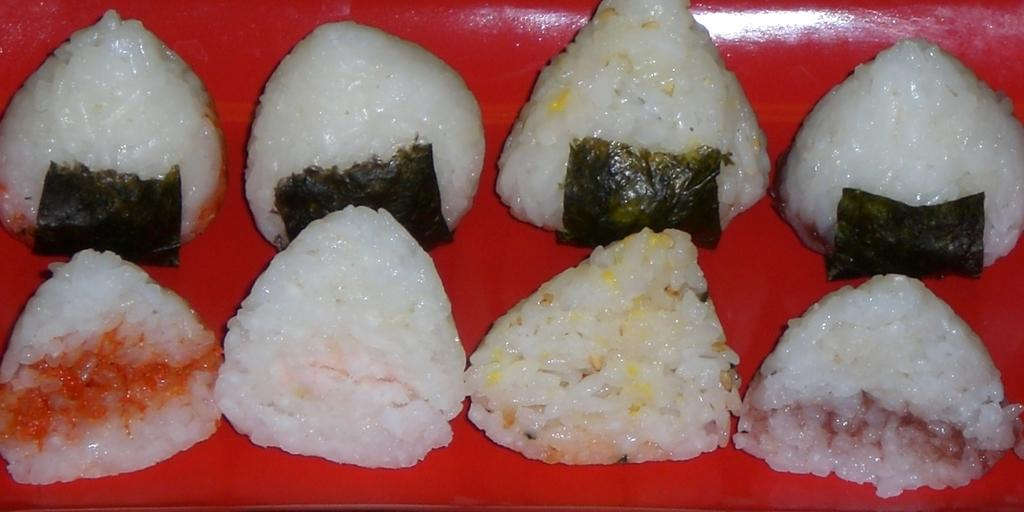How many pieces of rice cakes are visible in the image? There are eight pieces of rice cakes in the image. Where are the rice cakes placed? The rice cakes are placed on a plate. What is the color of the plate? The plate is red in color. What type of cord is used to hold the rice cakes together in the image? There is no cord present in the image; the rice cakes are placed individually on the plate. 